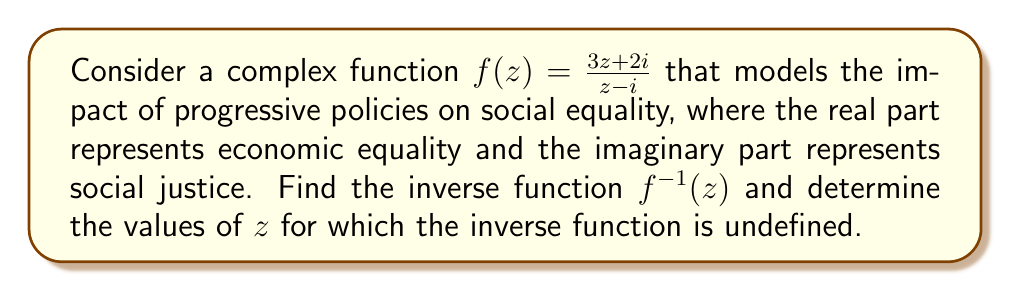What is the answer to this math problem? To find the inverse of the complex function $f(z) = \frac{3z+2i}{z-i}$, we'll follow these steps:

1) Let $w = f(z) = \frac{3z+2i}{z-i}$

2) Multiply both sides by $(z-i)$:
   $w(z-i) = 3z+2i$

3) Expand:
   $wz - wi = 3z + 2i$

4) Rearrange terms:
   $wz - 3z = wi + 2i$
   $z(w-3) = i(w+2)$

5) Solve for $z$:
   $z = \frac{i(w+2)}{w-3}$

6) This gives us the inverse function:
   $f^{-1}(w) = \frac{i(w+2)}{w-3}$

7) To find where the inverse function is undefined, we set the denominator to zero:
   $w - 3 = 0$
   $w = 3$

Therefore, the inverse function is undefined when $w = 3$.

In the context of our model, this means the inverse function breaks down when the impact of progressive policies reaches a certain threshold (represented by the complex number 3), suggesting a potential tipping point in the effectiveness of these policies.
Answer: The inverse function is $f^{-1}(z) = \frac{i(z+2)}{z-3}$, and it is undefined when $z = 3$. 